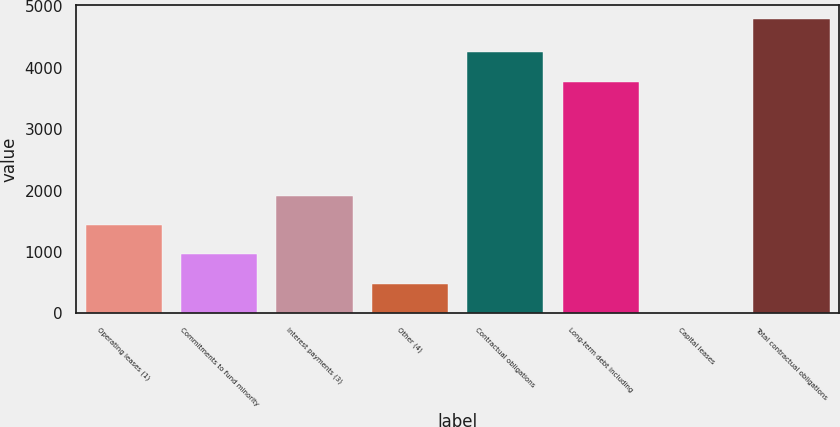Convert chart to OTSL. <chart><loc_0><loc_0><loc_500><loc_500><bar_chart><fcel>Operating leases (1)<fcel>Commitments to fund minority<fcel>Interest payments (3)<fcel>Other (4)<fcel>Contractual obligations<fcel>Long-term debt including<fcel>Capital leases<fcel>Total contractual obligations<nl><fcel>1437.5<fcel>959<fcel>1916<fcel>480.5<fcel>4252.5<fcel>3774<fcel>2<fcel>4787<nl></chart> 